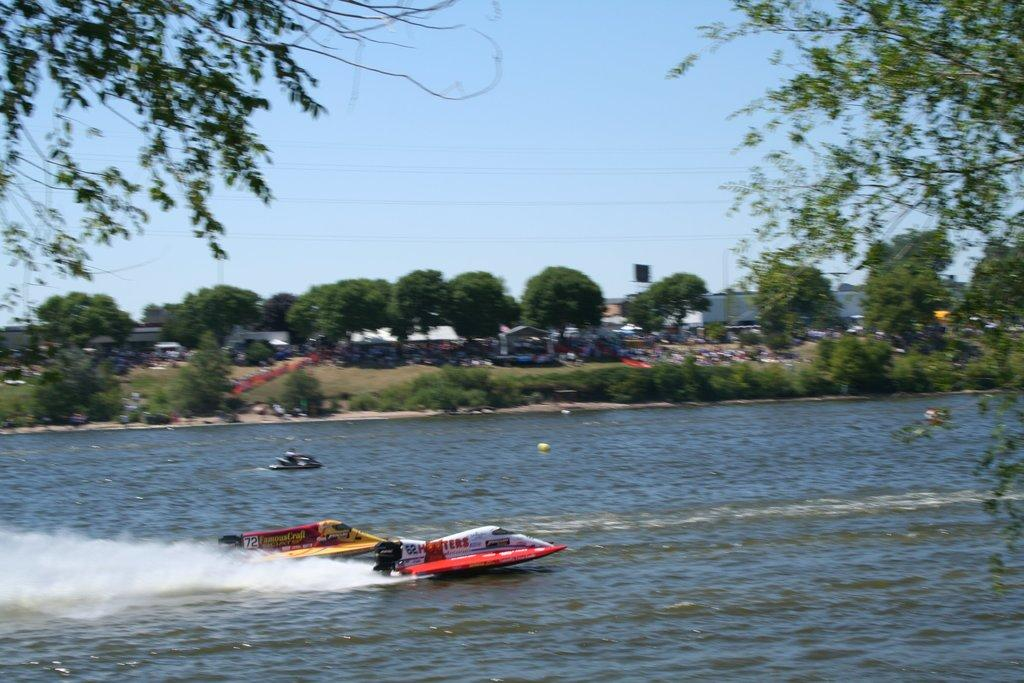What is the main subject of the image? The main subject of the image is a boat. Where is the boat located? The boat is on the water. What can be seen in the background of the image? There are trees in the background of the image. What is visible above the boat? The sky is visible in the image. What time of day is it in the image, and how does the boat smash through the water? The time of day is not mentioned in the image, and the boat is not shown smashing through the water; it is simply floating on the water. 